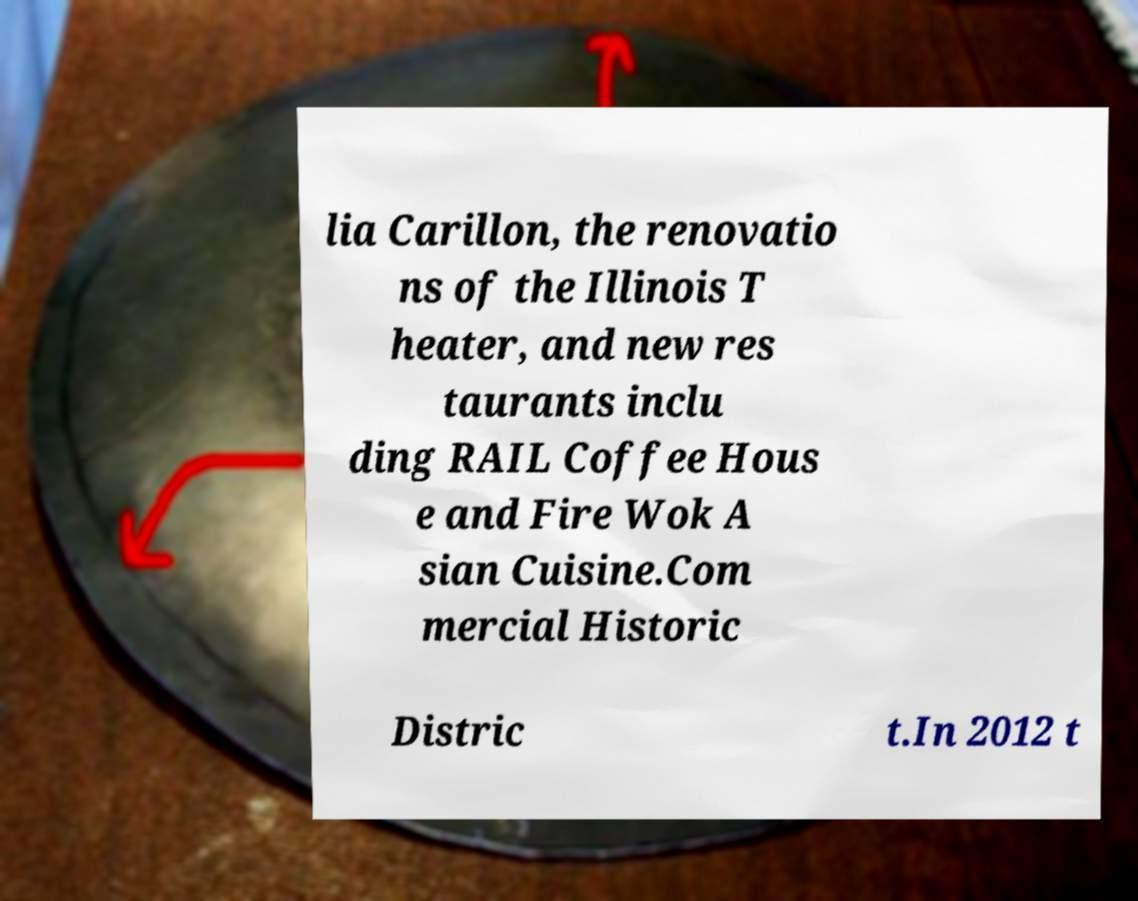Can you read and provide the text displayed in the image?This photo seems to have some interesting text. Can you extract and type it out for me? lia Carillon, the renovatio ns of the Illinois T heater, and new res taurants inclu ding RAIL Coffee Hous e and Fire Wok A sian Cuisine.Com mercial Historic Distric t.In 2012 t 